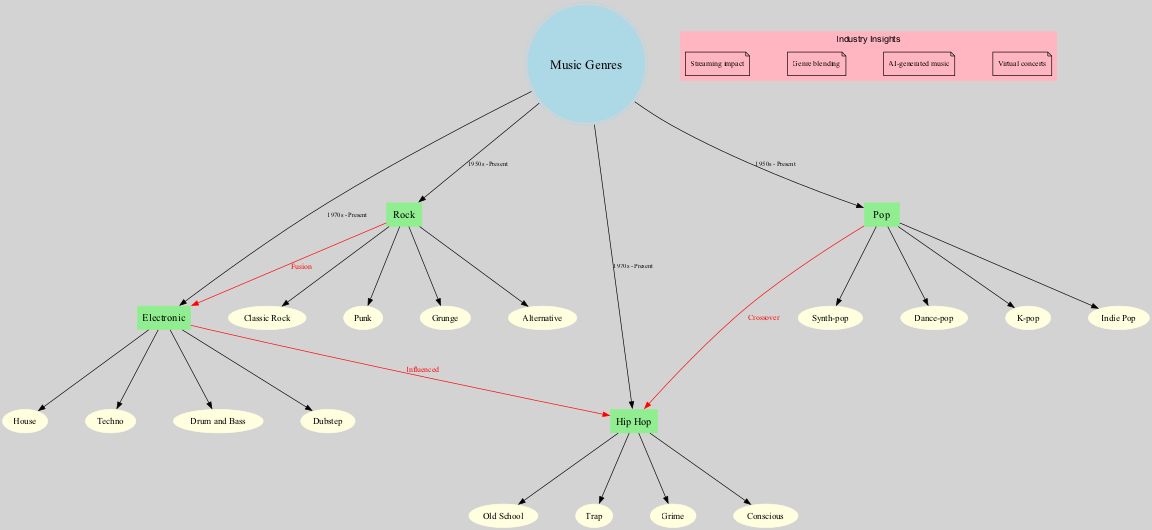What is the central node of the diagram? The central node is defined in the provided data as "Music Genres." Thus, the answer is obtained directly by referring to this information.
Answer: Music Genres How many main branches are there? The diagram contains four main branches: Electronic, Rock, Hip Hop, and Pop. We can count these directly from the provided data.
Answer: 4 Which genre has "Crossover" as a connection label? The connection labeled "Crossover" is from Pop to Hip Hop. This is identified in the connections section of the data.
Answer: Pop What are the sub-genres of Rock? The sub-genres listed under Rock in the data are Classic Rock, Punk, Grunge, and Alternative. These can be found under the main branch for Rock in the information provided.
Answer: Classic Rock, Punk, Grunge, Alternative What genre influenced Hip Hop? The diagram indicates that Electronic influenced Hip Hop. This connection is explicitly mentioned in the connections section of the data.
Answer: Electronic How many sub-genres are under Electronic? The Electronic genre contains four sub-genres: House, Techno, Drum and Bass, and Dubstep. This can be determined by looking at the sub_genres field of the Electronic branch.
Answer: 4 Which main branch is connected to Electronic by the label "Fusion"? The branch that connects to Electronic with the label "Fusion" is Rock. This can be found in the connections section, where the relationship between these two is specified.
Answer: Rock What insights are mentioned in the industry insights section? The insights mentioned include Streaming impact, Genre blending, AI-generated music, and Virtual concerts. These insights are listed in the provided data related to industry insights.
Answer: Streaming impact, Genre blending, AI-generated music, Virtual concerts Which sub-genre of Hip Hop is considered "Conscious"? Conscious is directly listed as one of the sub-genres of Hip Hop in the data given under that branch. It can be identified simply by referencing the Hip Hop section.
Answer: Conscious 